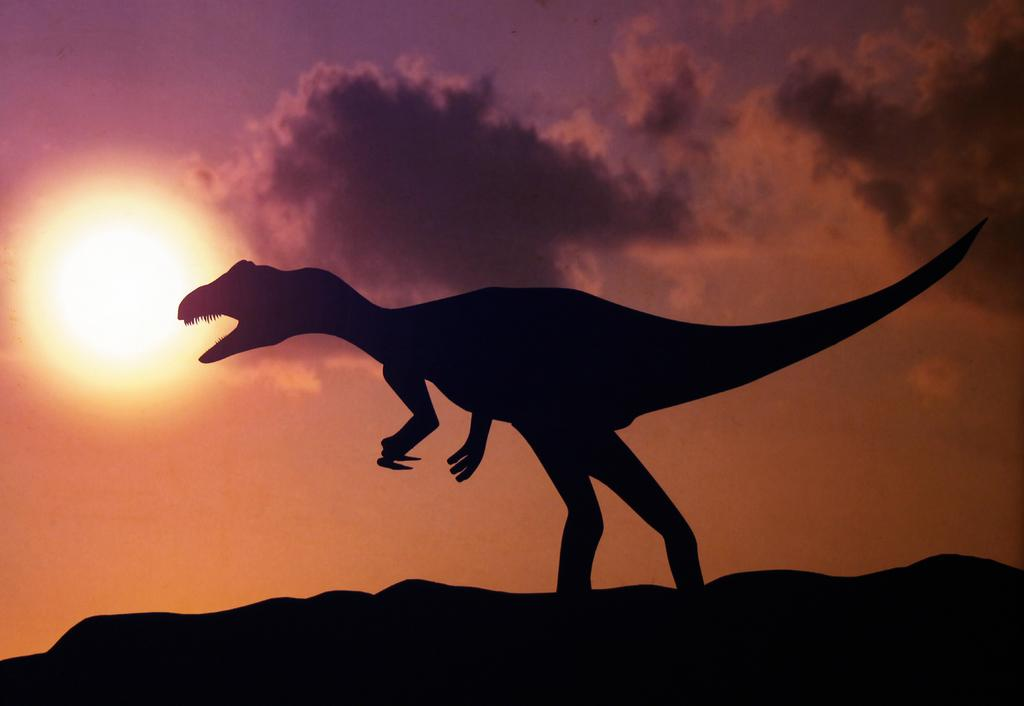What is the main subject of the image? There is a dinosaur in the image. What can be seen in the background of the image? Sky is visible in the background of the image. What is present in the sky? Clouds are present in the sky. Can you tell me how many girls are skating on the tub in the image? There are no girls, skating, or tubs present in the image; it features a dinosaur and clouds in the sky. 